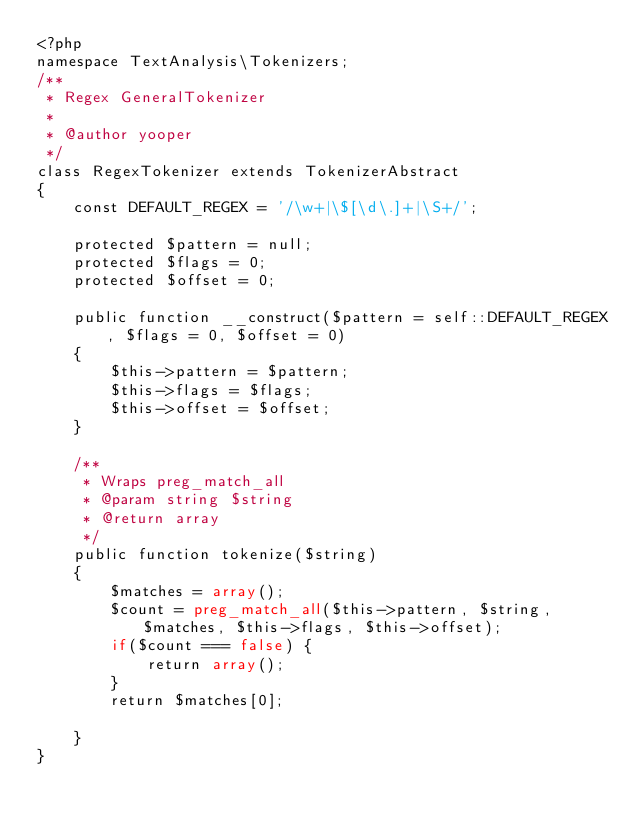Convert code to text. <code><loc_0><loc_0><loc_500><loc_500><_PHP_><?php
namespace TextAnalysis\Tokenizers;
/**
 * Regex GeneralTokenizer
 *
 * @author yooper
 */
class RegexTokenizer extends TokenizerAbstract 
{
    const DEFAULT_REGEX = '/\w+|\$[\d\.]+|\S+/';
    
    protected $pattern = null;
    protected $flags = 0;
    protected $offset = 0;
    
    public function __construct($pattern = self::DEFAULT_REGEX, $flags = 0, $offset = 0)
    {
        $this->pattern = $pattern;
        $this->flags = $flags;
        $this->offset = $offset;
    }
    
    /**
     * Wraps preg_match_all
     * @param string $string
     * @return array 
     */
    public function tokenize($string)
    {
        $matches = array();
        $count = preg_match_all($this->pattern, $string, $matches, $this->flags, $this->offset);
        if($count === false) { 
            return array();
        }
        return $matches[0];
        
    }
}
</code> 